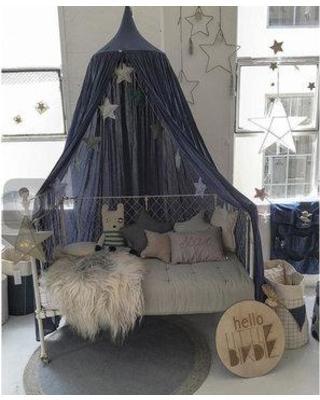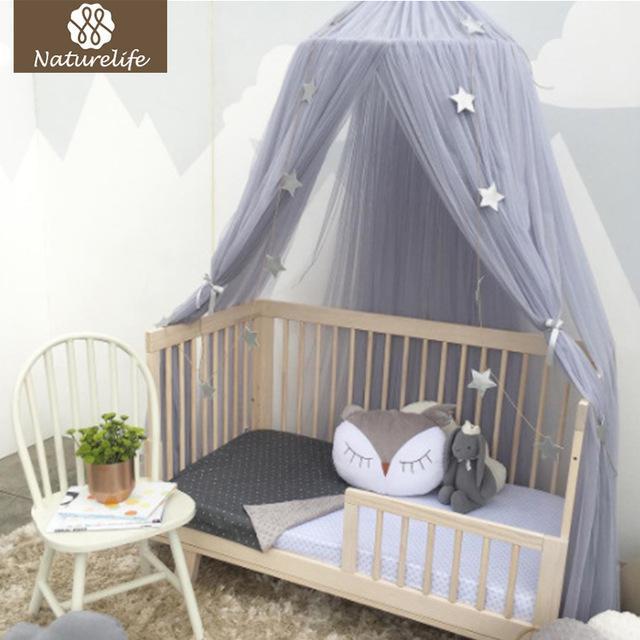The first image is the image on the left, the second image is the image on the right. Considering the images on both sides, is "The right image shows a gauzy light gray canopy with a garland of stars hung from the ceiling over a toddler bed with vertical bars and a chair with a plant on its seat next to it." valid? Answer yes or no. Yes. 